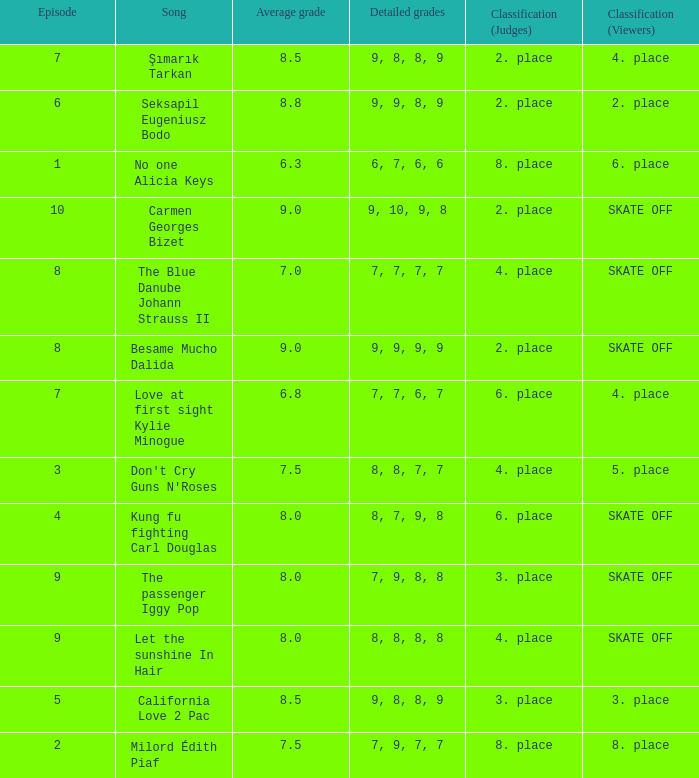Name the average grade for şımarık tarkan 8.5. 